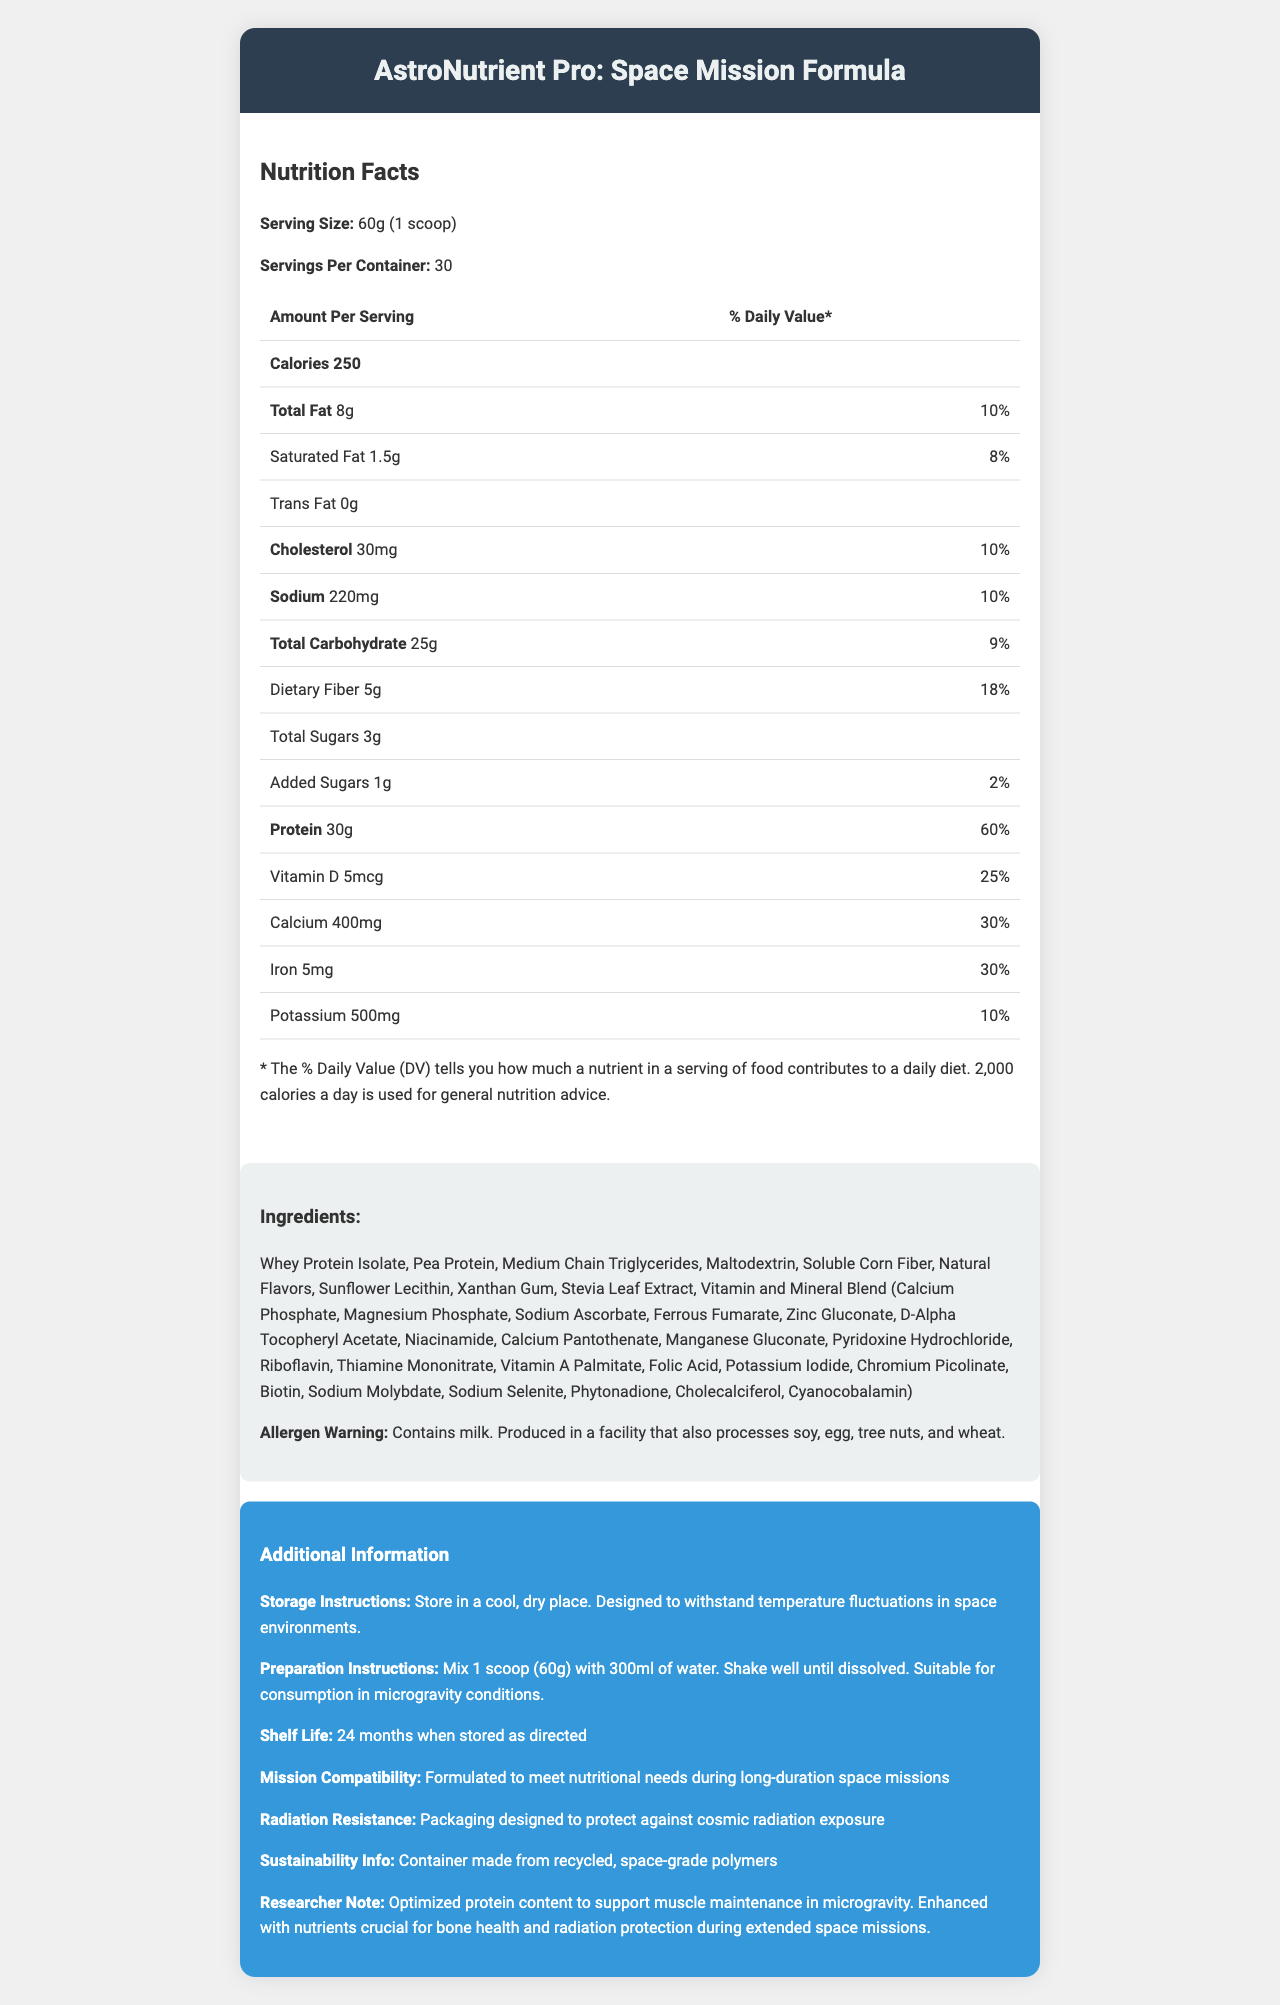what is the serving size? The serving size is listed at the beginning of the Nutrition Facts section as "Serving Size: 60g (1 scoop)".
Answer: 60g (1 scoop) how many calories are there per serving? The Calories per serving is provided in the document under the "Amount Per Serving" section.
Answer: 250 how much protein is there in one serving? The protein amount in one serving is listed in the "Nutrition Facts" table section as 30g.
Answer: 30g what percent of the daily value for protein is provided by one serving? The daily value percentage for protein is stated in the "Nutrition Facts" table as 60%.
Answer: 60% how much calcium is in one serving? The calcium content per serving is listed under the "Nutrition Facts" as 400mg.
Answer: 400mg which vitamin accounts for 67% of the daily value? A. Vitamin D B. Vitamin C C. Vitamin E D. Vitamin K Both Vitamin C (60mg) and Vitamin E (10mg) provide 67% of the daily value as per the document.
Answer: B and C how many servings are there per container? A. 20 B. 25 C. 30 D. 35 The document states the servings per container as 30.
Answer: C does the product contain any trans fat? The document lists trans fat as 0g under the "Nutrition Facts".
Answer: No is this product suitable for microgravity consumption? The preparation instructions clearly state that the product is suitable for consumption in microgravity conditions.
Answer: Yes summarize the main purpose of this document. The document includes various sections such as Nutrition Facts, ingredients, allergen warnings, storage, preparation instructions, and special features that highlight its suitability for space missions.
Answer: The document provides detailed nutrition information, ingredients, allergens, preparation instructions, and additional details about the AstroNutrient Pro: Space Mission Formula meal replacement shake, designed for long-duration space missions. what type of protein sources are used in this product? The listed ingredients include Whey Protein Isolate and Pea Protein.
Answer: Whey Protein Isolate, Pea Protein what is the shelf life of this product? The document specifies a shelf life of 24 months when stored as directed.
Answer: 24 months how much iron does a serving provide, and what percentage of the daily value? The document lists iron content as 5mg per serving, which is 30% of the daily value.
Answer: 5mg, 30% which ingredient is not listed in the document? A. Citrulline Malate B. Soluble Corn Fiber C. Xanthan Gum D. Stevia Leaf Extract Citrulline Malate is not listed among the ingredients, while Soluble Corn Fiber, Xanthan Gum, and Stevia Leaf Extract are included.
Answer: A what is the cautionary allergen information provided in the document? The allergen warning is explicitly mentioned in the ingredients section.
Answer: Contains milk. Produced in a facility that also processes soy, egg, tree nuts, and wheat. is the container made from space-grade polymers? True or False The sustainability info states that the container is made from recycled, space-grade polymers.
Answer: True describe the additional benefits of this product specific to space missions. The special features mentioned in the additional information section explain how the product supports muscle and bone health, radiation protection, and space mission compatibility, including specific packaging design.
Answer: The product is optimized for muscle maintenance in microgravity, contains nutrients for bone health and radiation protection, has packaging designed to protect against cosmic radiation, and is suitable for microgravity consumption. what is the primary research note about this product? The researcher note section highlights the primary research focus on optimizing protein content for muscle maintenance and essential nutrients for bone health and radiation protection in space.
Answer: Optimized protein content to support muscle maintenance in microgravity. Enhanced with nutrients crucial for bone health and radiation protection during extended space missions. 